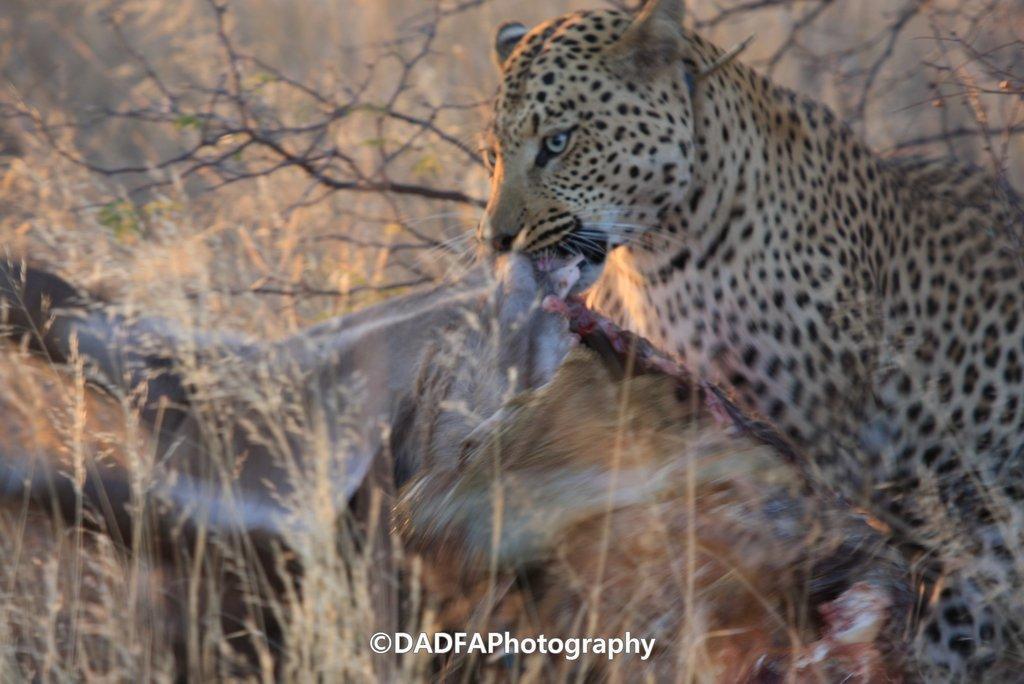Could you give a brief overview of what you see in this image? In this picture I can see a cheetah eating an animal, and in the background there are trees and there is a watermark on the image. 